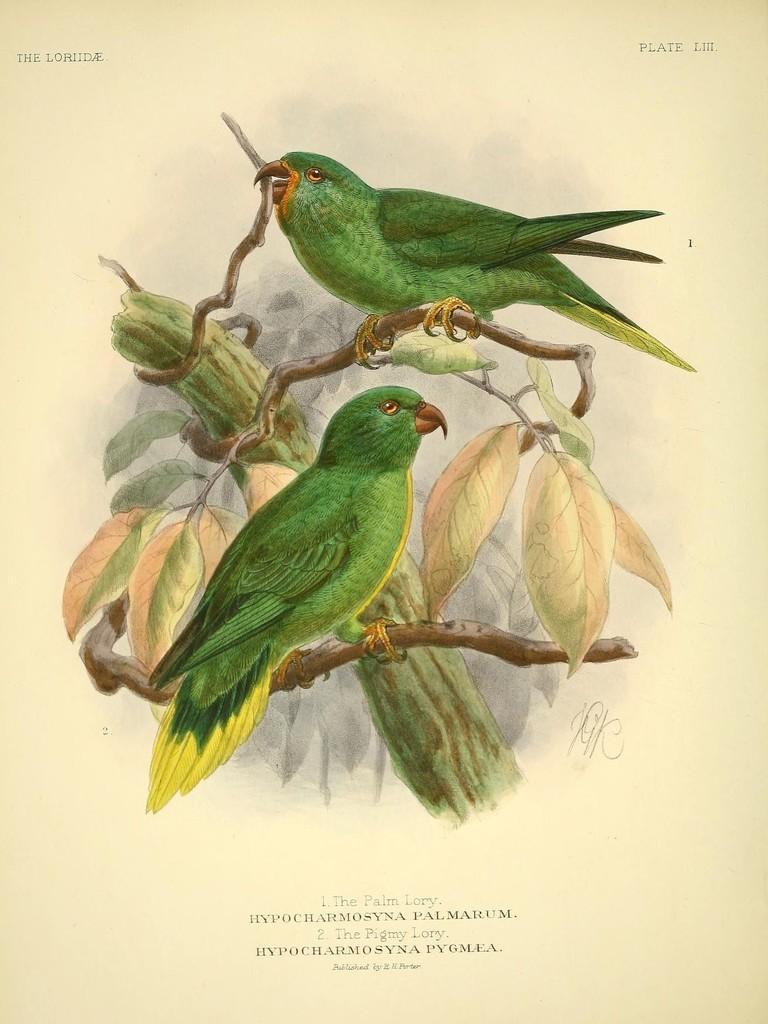Describe this image in one or two sentences. It is a painted image. In the center of the image there are parrots on the tree branch. At the bottom of the image there is some text written on it. 